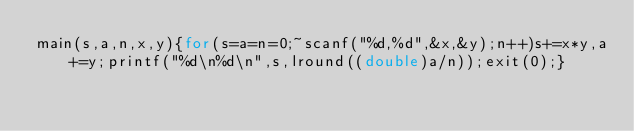<code> <loc_0><loc_0><loc_500><loc_500><_C_>main(s,a,n,x,y){for(s=a=n=0;~scanf("%d,%d",&x,&y);n++)s+=x*y,a+=y;printf("%d\n%d\n",s,lround((double)a/n));exit(0);}</code> 